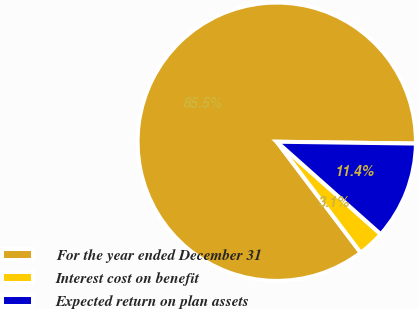Convert chart. <chart><loc_0><loc_0><loc_500><loc_500><pie_chart><fcel>For the year ended December 31<fcel>Interest cost on benefit<fcel>Expected return on plan assets<nl><fcel>85.53%<fcel>3.12%<fcel>11.36%<nl></chart> 